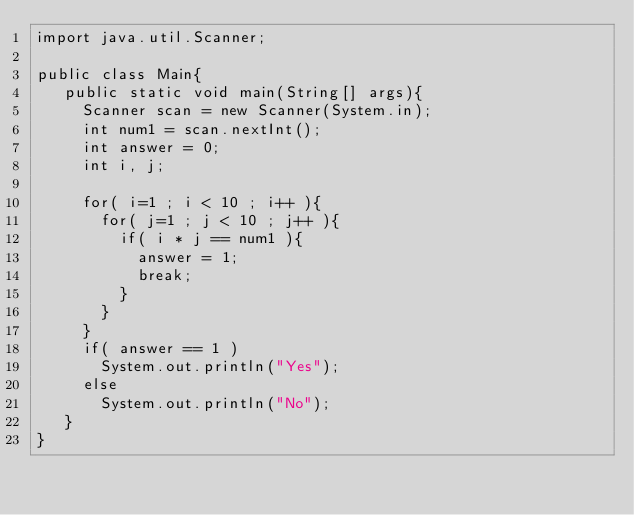Convert code to text. <code><loc_0><loc_0><loc_500><loc_500><_Java_>import java.util.Scanner;

public class Main{
   public static void main(String[] args){
     Scanner scan = new Scanner(System.in);
     int num1 = scan.nextInt();
     int answer = 0;
     int i, j;
     
     for( i=1 ; i < 10 ; i++ ){
       for( j=1 ; j < 10 ; j++ ){
         if( i * j == num1 ){
           answer = 1;
           break;
         }
       }
     }
     if( answer == 1 )
       System.out.println("Yes");
     else
       System.out.println("No");
   }
}</code> 